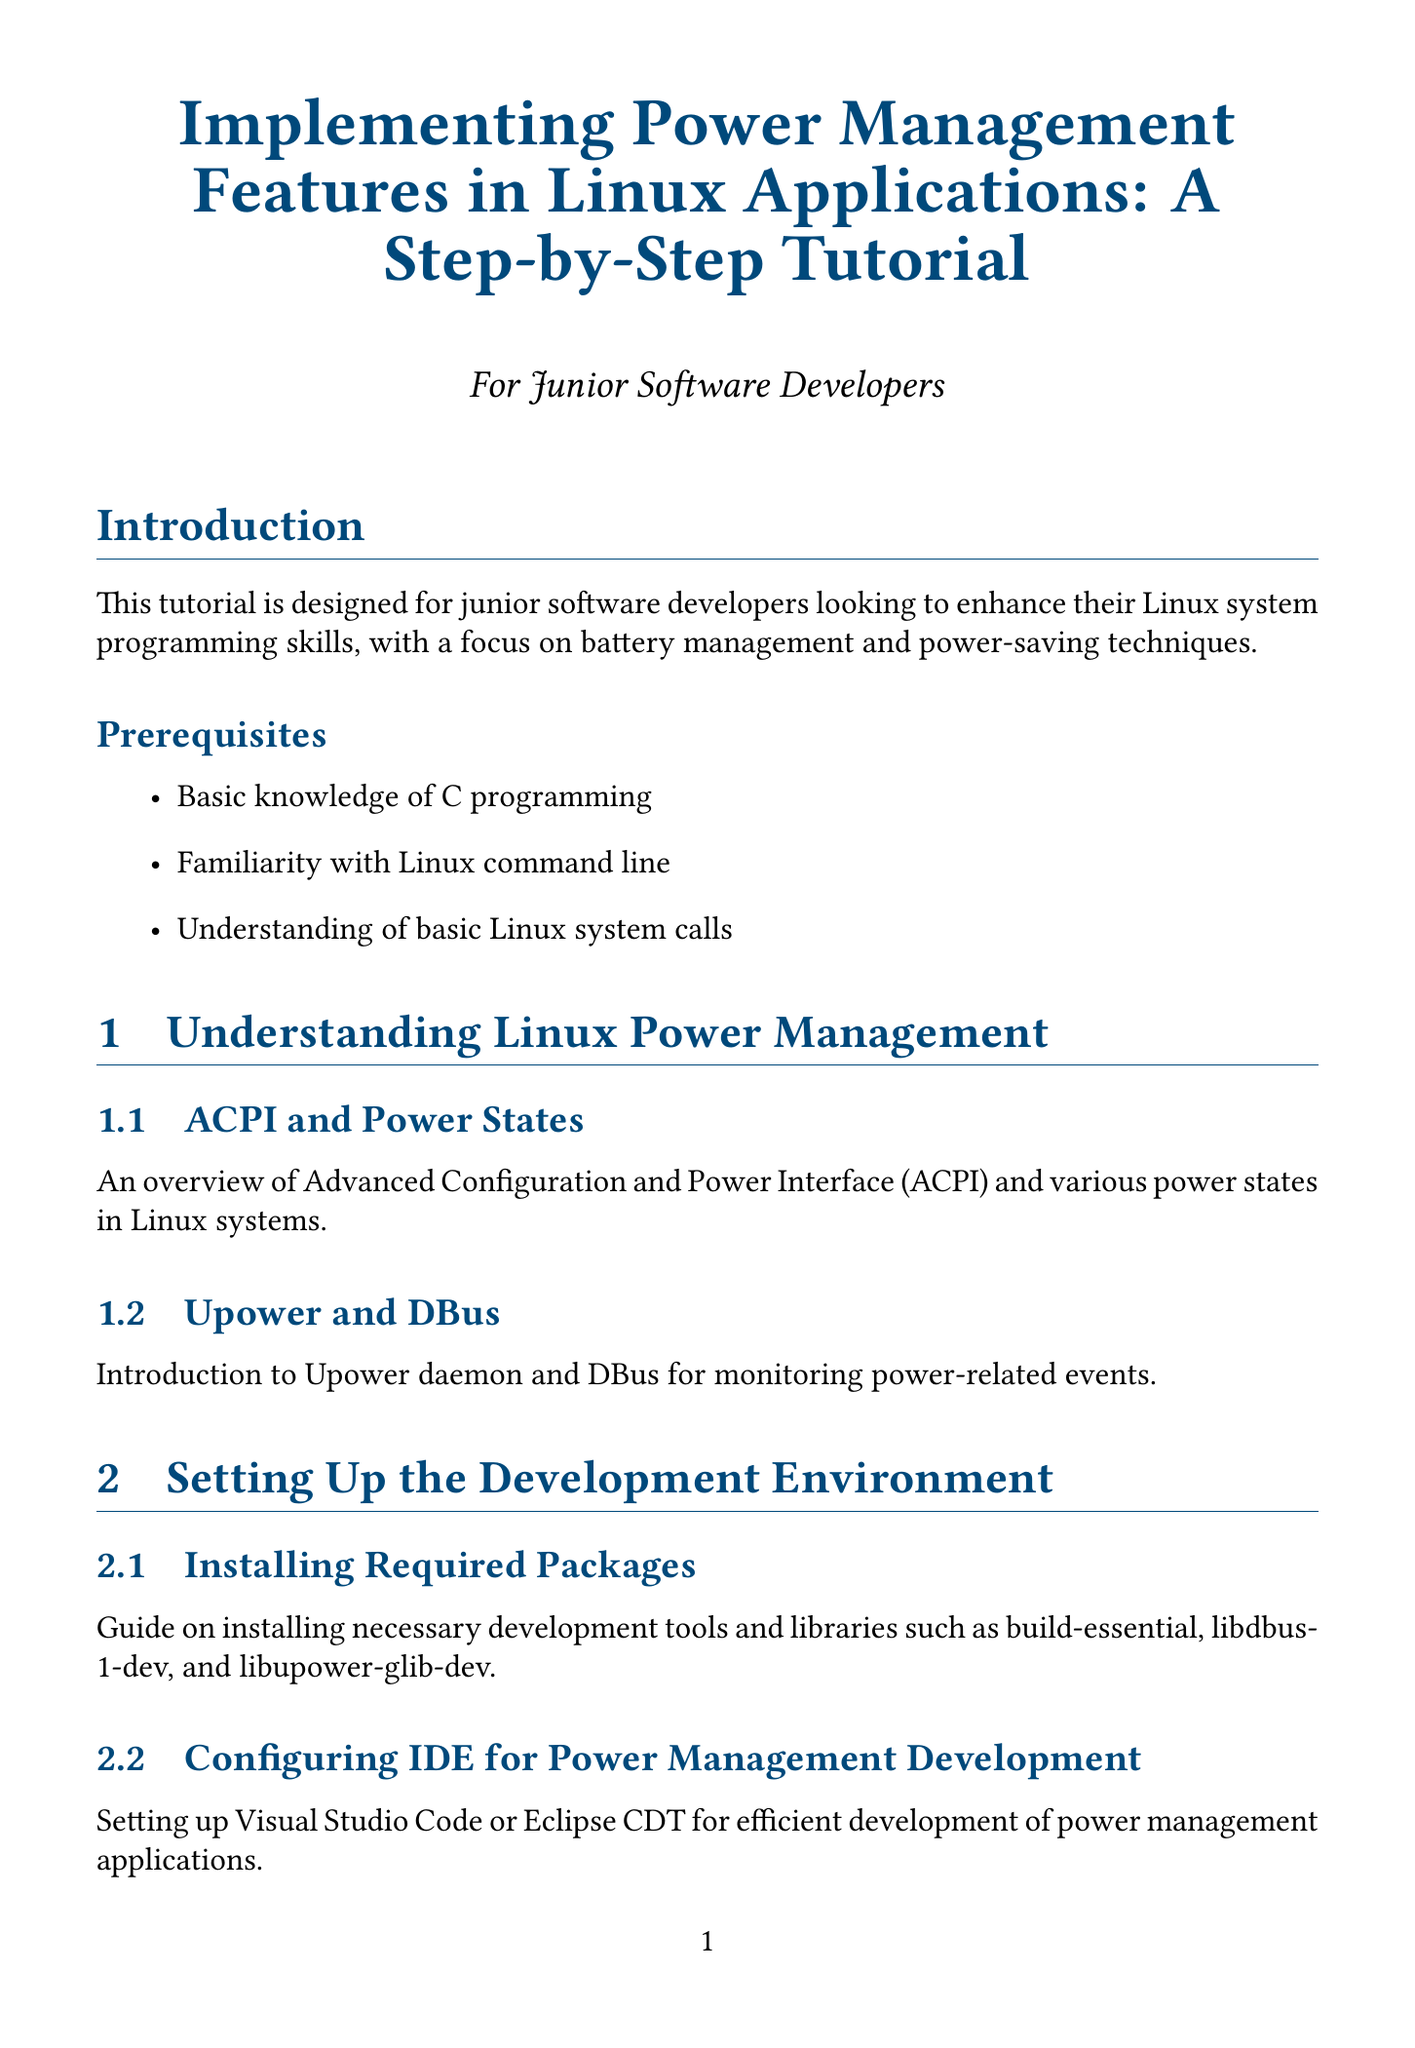What is the title of the tutorial? The title of the tutorial is specified at the beginning of the document.
Answer: Implementing Power Management Features in Linux Applications: A Step-by-Step Tutorial What is one prerequisite for this tutorial? Prerequisites are listed in the introduction section of the document.
Answer: Basic knowledge of C programming Which chapter discusses UPower and DBus? The chapter discussing UPower and DBus is explicitly mentioned in the contents of the document.
Answer: Understanding Linux Power Management How many sections are there in the chapter about Monitoring Battery Status? The number of sections in a chapter is indicated in the structure of the document.
Answer: Two What tool is used for power analysis as stated in the Testing and Debugging chapter? The document contains specific tools mentioned in the Testing and Debugging chapter.
Answer: powertop Which flag is mentioned for managing device power states? The specific flag is mentioned in the Implementing Power-Saving Techniques section of the document.
Answer: PM_SUSPEND_TO_IDLE What is a recommended next step after completing the tutorial? Next steps are listed in the conclusion section of the document.
Answer: Explore kernel-level power management techniques What is the focus of this tutorial? The focus is mentioned in the introduction overview of the document.
Answer: Battery management and power-saving techniques 